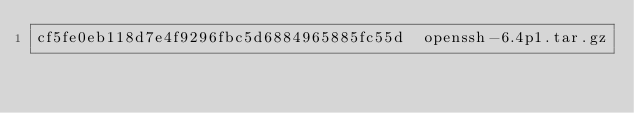Convert code to text. <code><loc_0><loc_0><loc_500><loc_500><_SML_>cf5fe0eb118d7e4f9296fbc5d6884965885fc55d  openssh-6.4p1.tar.gz
</code> 